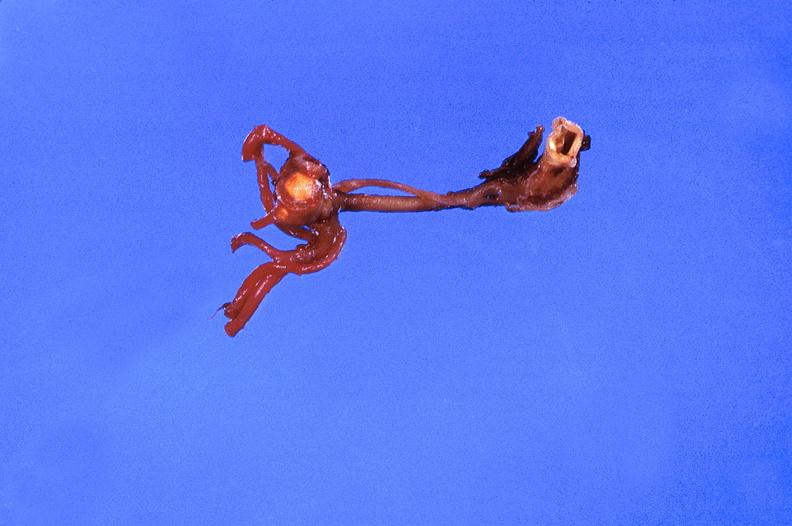s vasculature present?
Answer the question using a single word or phrase. Yes 